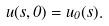<formula> <loc_0><loc_0><loc_500><loc_500>u ( s , 0 ) = u _ { 0 } ( s ) .</formula> 